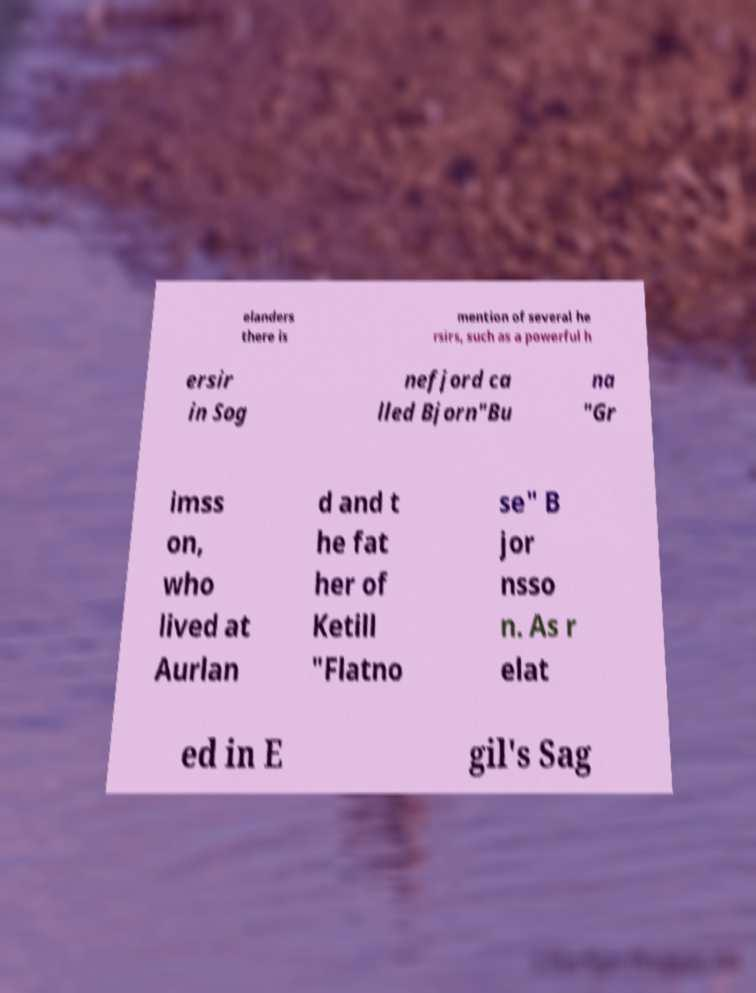For documentation purposes, I need the text within this image transcribed. Could you provide that? elanders there is mention of several he rsirs, such as a powerful h ersir in Sog nefjord ca lled Bjorn"Bu na "Gr imss on, who lived at Aurlan d and t he fat her of Ketill "Flatno se" B jor nsso n. As r elat ed in E gil's Sag 